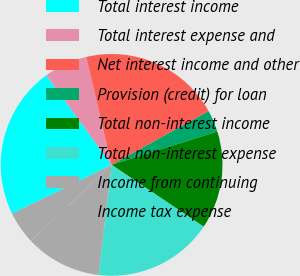<chart> <loc_0><loc_0><loc_500><loc_500><pie_chart><fcel>Total interest income<fcel>Total interest expense and<fcel>Net interest income and other<fcel>Provision (credit) for loan<fcel>Total non-interest income<fcel>Total non-interest expense<fcel>Income from continuing<fcel>Income tax expense<nl><fcel>22.22%<fcel>6.35%<fcel>20.63%<fcel>3.18%<fcel>14.28%<fcel>17.46%<fcel>11.11%<fcel>4.77%<nl></chart> 